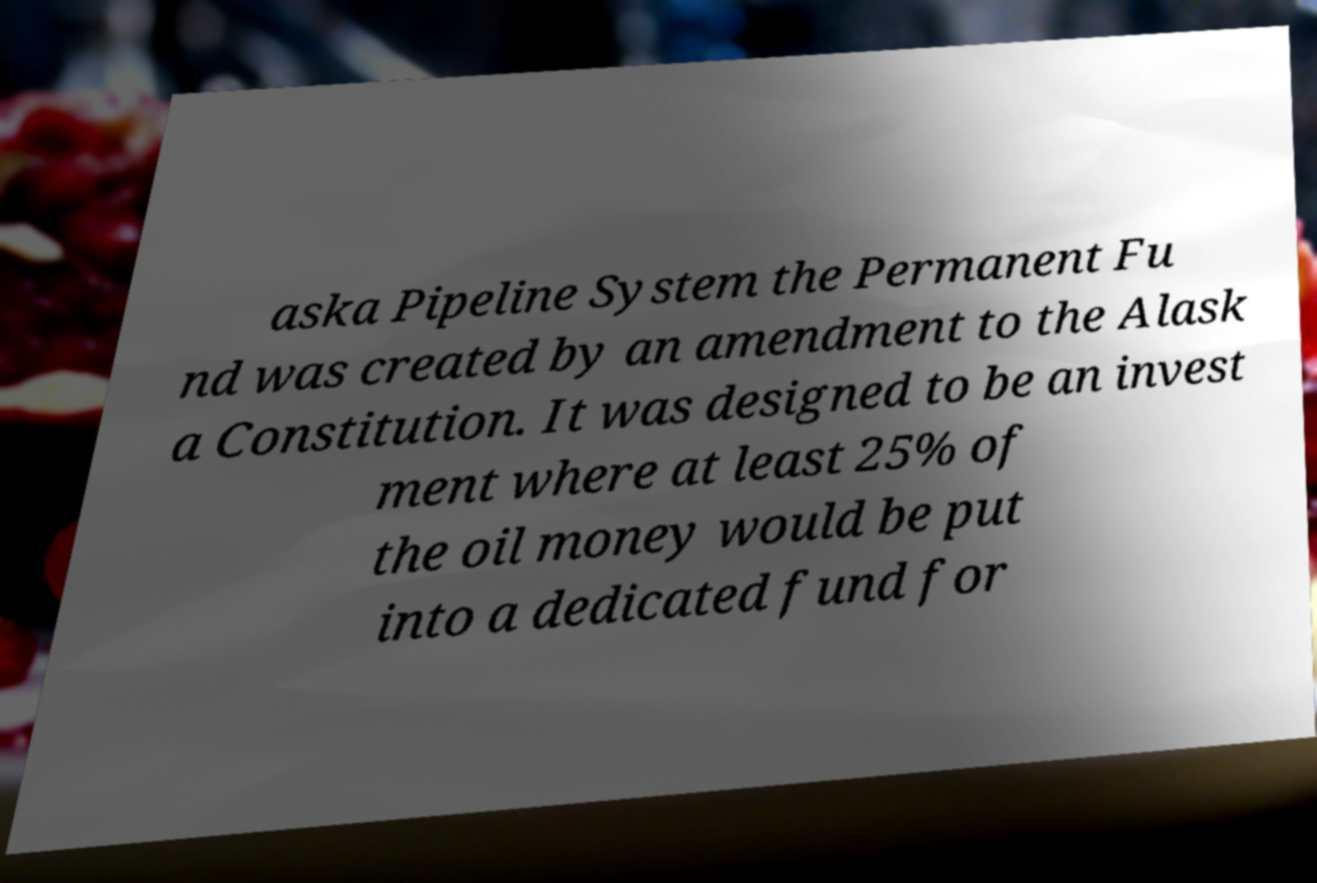Can you accurately transcribe the text from the provided image for me? aska Pipeline System the Permanent Fu nd was created by an amendment to the Alask a Constitution. It was designed to be an invest ment where at least 25% of the oil money would be put into a dedicated fund for 